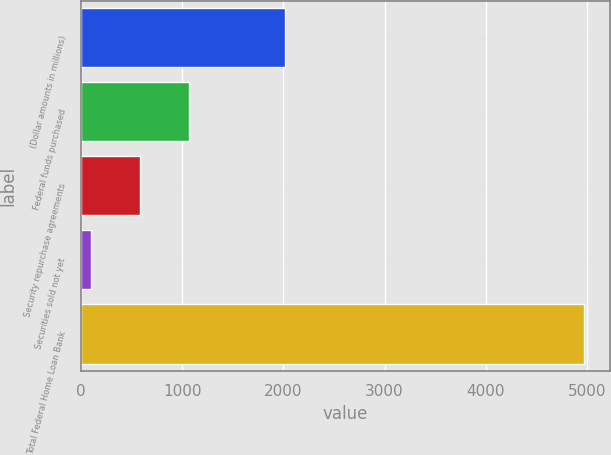<chart> <loc_0><loc_0><loc_500><loc_500><bar_chart><fcel>(Dollar amounts in millions)<fcel>Federal funds purchased<fcel>Security repurchase agreements<fcel>Securities sold not yet<fcel>Total Federal Home Loan Bank<nl><fcel>2017<fcel>1071.2<fcel>583.1<fcel>95<fcel>4976<nl></chart> 